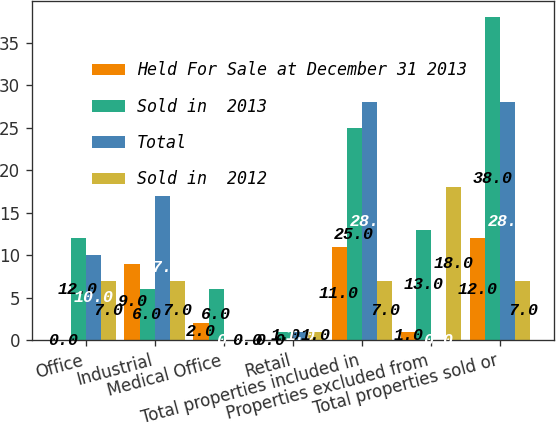Convert chart. <chart><loc_0><loc_0><loc_500><loc_500><stacked_bar_chart><ecel><fcel>Office<fcel>Industrial<fcel>Medical Office<fcel>Retail<fcel>Total properties included in<fcel>Properties excluded from<fcel>Total properties sold or<nl><fcel>Held For Sale at December 31 2013<fcel>0<fcel>9<fcel>2<fcel>0<fcel>11<fcel>1<fcel>12<nl><fcel>Sold in  2013<fcel>12<fcel>6<fcel>6<fcel>1<fcel>25<fcel>13<fcel>38<nl><fcel>Total<fcel>10<fcel>17<fcel>0<fcel>1<fcel>28<fcel>0<fcel>28<nl><fcel>Sold in  2012<fcel>7<fcel>7<fcel>0<fcel>1<fcel>7<fcel>18<fcel>7<nl></chart> 